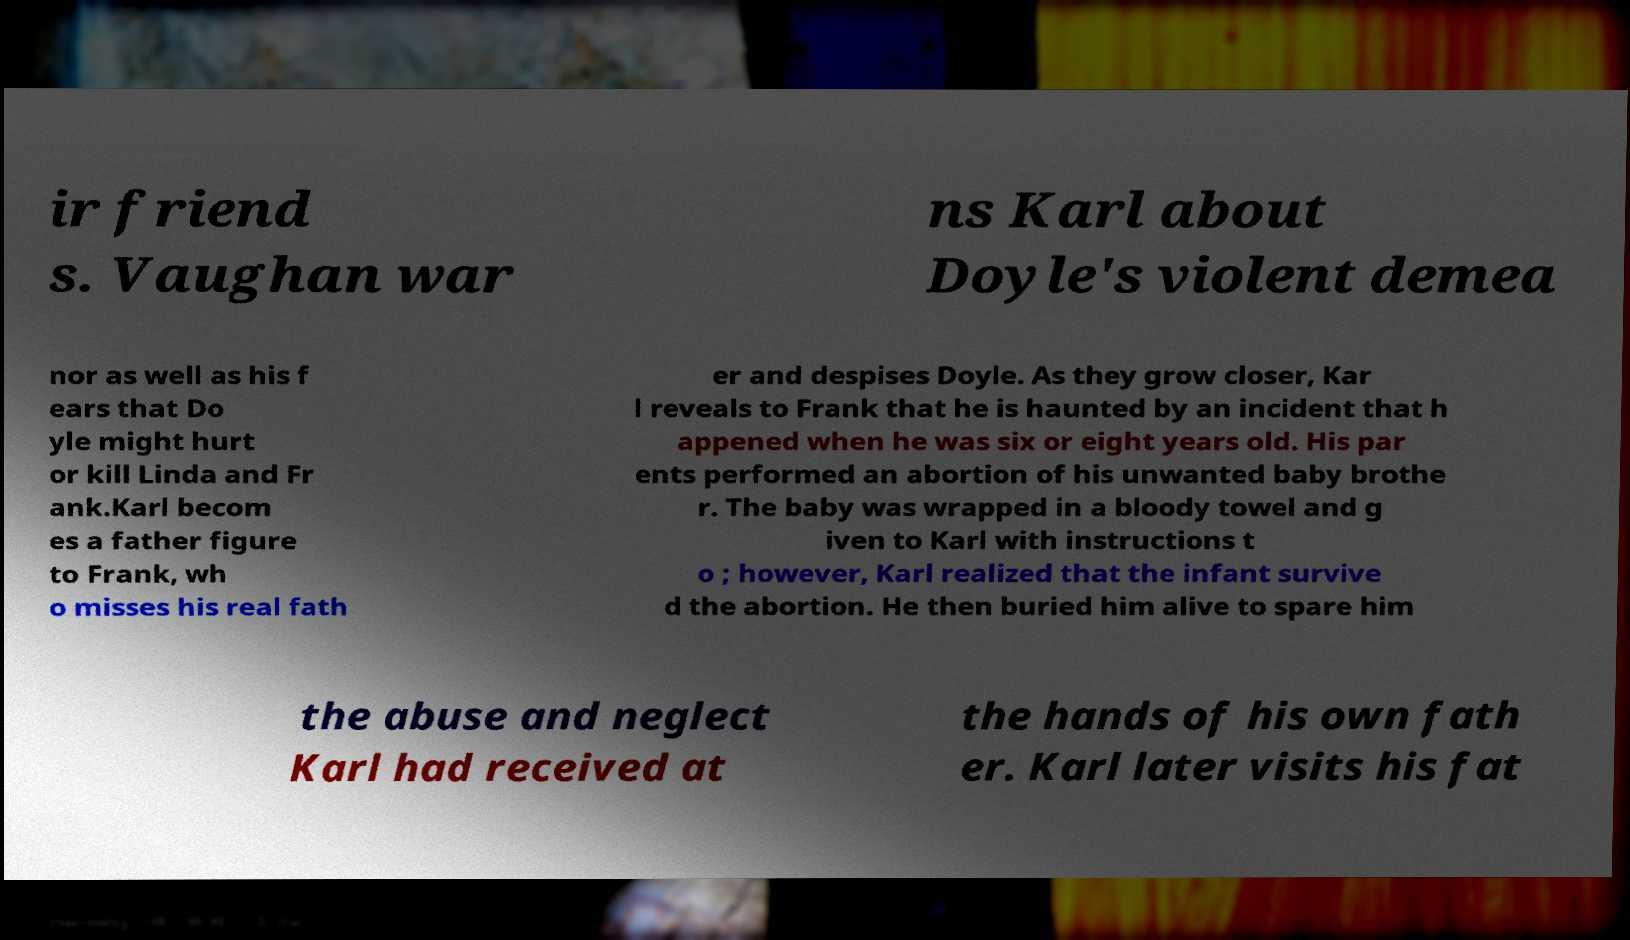There's text embedded in this image that I need extracted. Can you transcribe it verbatim? ir friend s. Vaughan war ns Karl about Doyle's violent demea nor as well as his f ears that Do yle might hurt or kill Linda and Fr ank.Karl becom es a father figure to Frank, wh o misses his real fath er and despises Doyle. As they grow closer, Kar l reveals to Frank that he is haunted by an incident that h appened when he was six or eight years old. His par ents performed an abortion of his unwanted baby brothe r. The baby was wrapped in a bloody towel and g iven to Karl with instructions t o ; however, Karl realized that the infant survive d the abortion. He then buried him alive to spare him the abuse and neglect Karl had received at the hands of his own fath er. Karl later visits his fat 